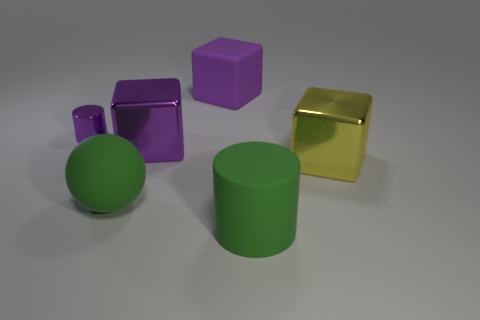Subtract all shiny blocks. How many blocks are left? 1 Add 3 small blue spheres. How many objects exist? 9 Subtract all yellow blocks. How many blocks are left? 2 Subtract all cylinders. How many objects are left? 4 Subtract 1 blocks. How many blocks are left? 2 Subtract all yellow cubes. Subtract all cyan spheres. How many cubes are left? 2 Subtract all blue cylinders. How many purple blocks are left? 2 Subtract all green cylinders. Subtract all spheres. How many objects are left? 4 Add 5 purple blocks. How many purple blocks are left? 7 Add 5 large red matte balls. How many large red matte balls exist? 5 